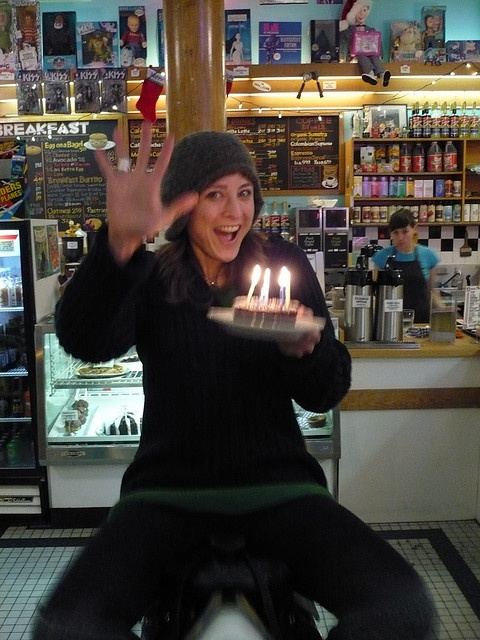Describe the objects in this image and their specific colors. I can see people in gray, black, brown, and maroon tones, refrigerator in gray, black, darkgray, and ivory tones, people in gray, black, blue, and brown tones, cake in gray and tan tones, and bottle in gray, maroon, black, and brown tones in this image. 